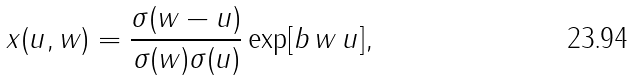Convert formula to latex. <formula><loc_0><loc_0><loc_500><loc_500>x ( u , w ) = { \frac { \sigma ( w - u ) } { \sigma ( w ) \sigma ( u ) } } \exp [ b \, w \, u ] ,</formula> 